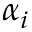Convert formula to latex. <formula><loc_0><loc_0><loc_500><loc_500>\alpha _ { i }</formula> 